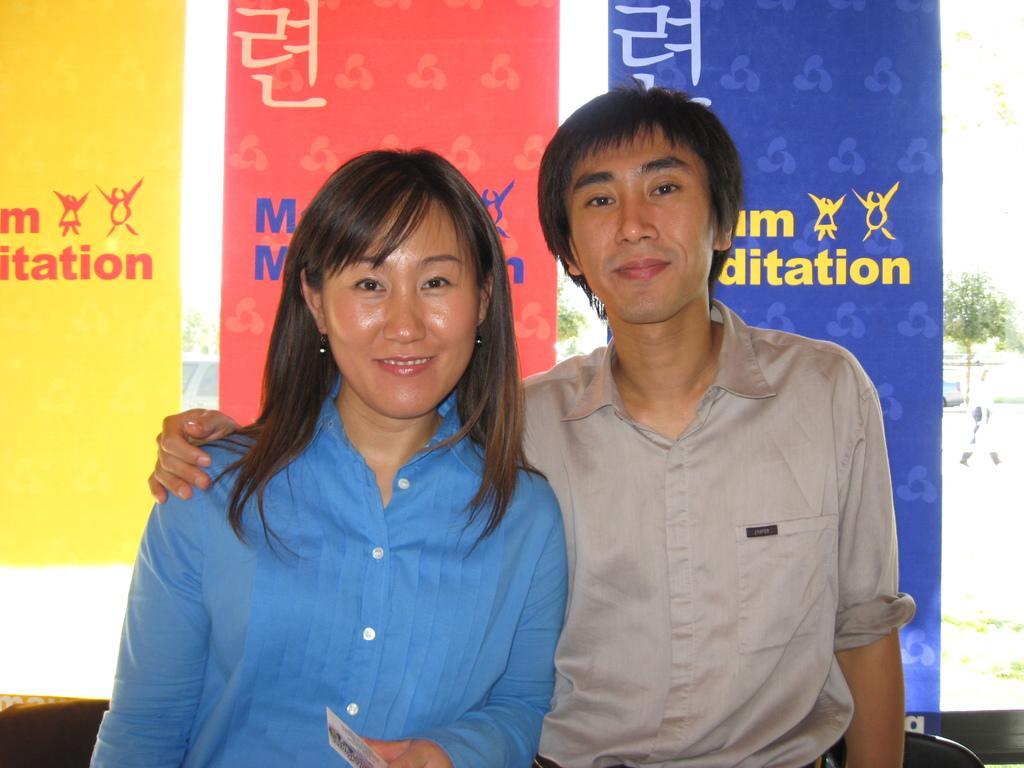Could you give a brief overview of what you see in this image? In this picture I can see there is a man and a woman standing, they are smiling and there are a few banners in the backdrop and I can see there is a plant in the backdrop. 